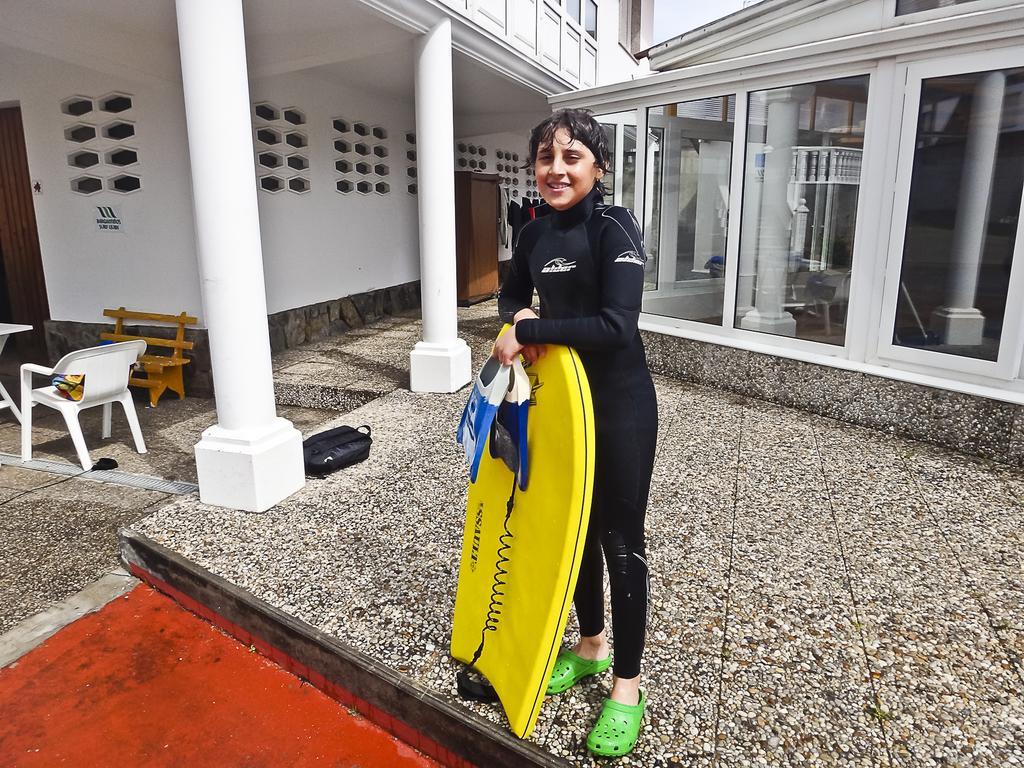Can you describe this image briefly? In this image there is a person standing on a floor, holding a surfing board, in the background there are buildings, chairs and a bench. 